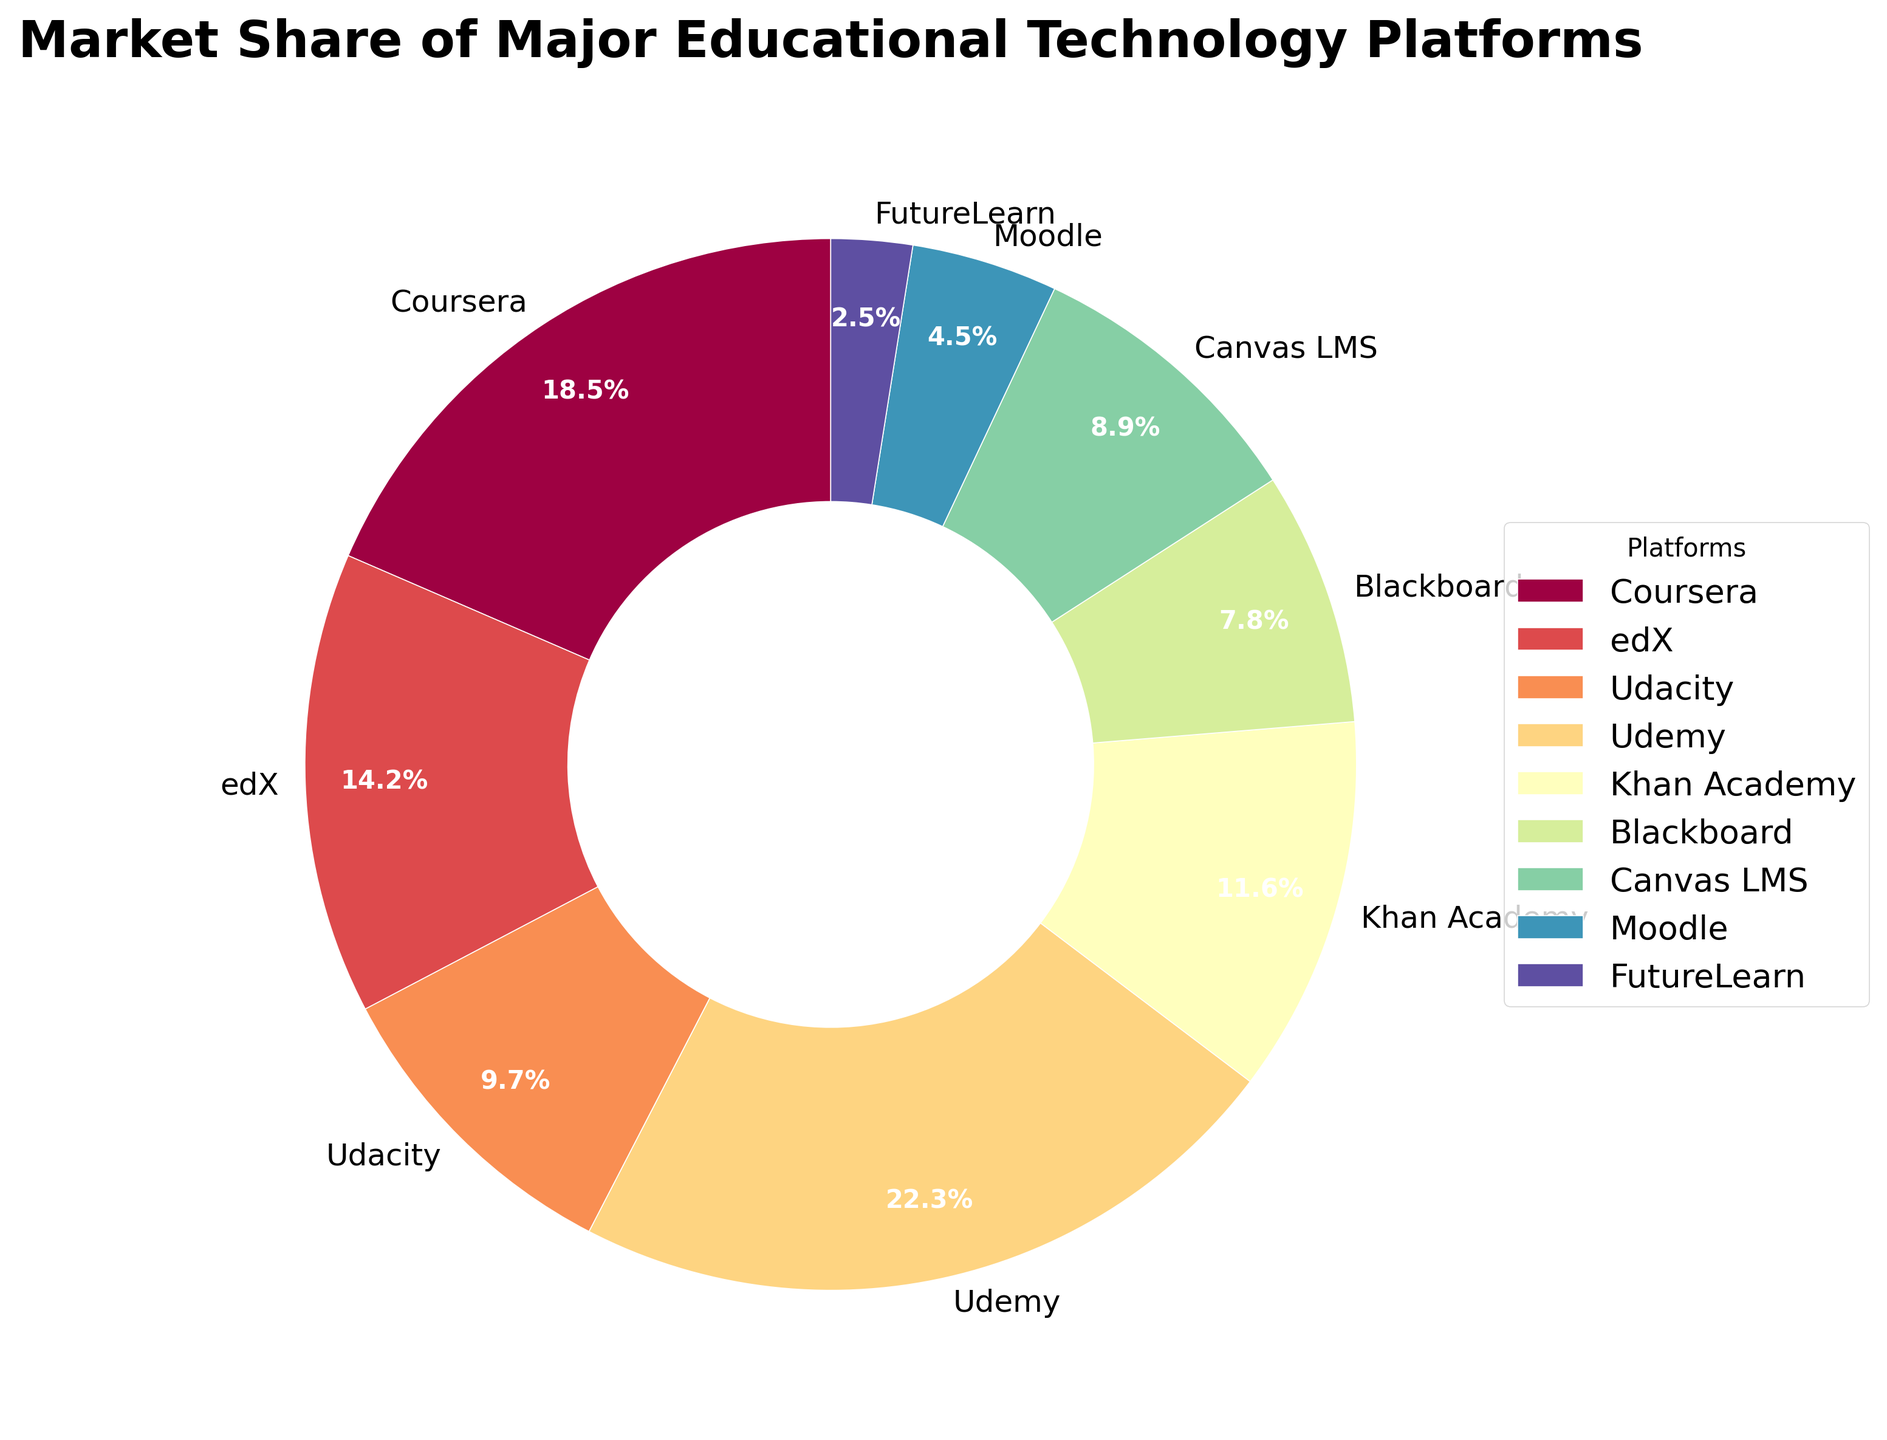Which platform has the largest market share? By looking at the pie chart, we can identify the platform with the largest slice. The label on the largest slice indicates "Udemy" with a market share of 22.3%.
Answer: Udemy Which two platforms together hold more than 30% market share? Summing up the shares of each platform, we see that Udemy has 22.3% and Coursera has 18.5%. Together, they account for 40.8%, which is more than 30%.
Answer: Udemy and Coursera Which platform has the smallest market share? By identifying the smallest slice in the pie chart, we can see that the label on it indicates "FutureLearn" with a market share of 2.5%.
Answer: FutureLearn What is the combined market share of edX and Khan Academy? Adding the market shares of edX (14.2%) and Khan Academy (11.6%), we get 14.2 + 11.6 = 25.8%.
Answer: 25.8% How does the market share of Blackboard compare to Canvas LMS? The market share of Blackboard is 7.8% whereas Canvas LMS has 8.9%. Comparing these, Canvas LMS has a slightly larger share.
Answer: Canvas LMS Between Coursera and Udacity, which platform has a higher market share, and by how much? Coursera has a market share of 18.5%, and Udacity has 9.7%. The difference in their market shares is 18.5 - 9.7 = 8.8%.
Answer: Coursera by 8.8% If the platforms were grouped into "Top 3" and "Others", what would be the market share of each group? The Top 3 platforms are Udemy (22.3%), Coursera (18.5%), and edX (14.2%). Their combined share is 22.3 + 18.5 + 14.2 = 55%. The Others group includes the remaining platforms, summing up to 45%.
Answer: Top 3: 55%, Others: 45% What is the average market share of the platforms with less than 10% market share? The platforms with less than 10% are Udacity (9.7%), Blackboard (7.8%), Canvas LMS (8.9%), Moodle (4.5%), and FutureLearn (2.5%). Their shares sum to 9.7 + 7.8 + 8.9 + 4.5 + 2.5 = 33.4%. The average is 33.4 / 5 = 6.68%.
Answer: 6.68% Which platforms have a market share between 10% and 20%? By examining the pie chart, the platforms with market shares in this range are Coursera (18.5%), edX (14.2%), and Khan Academy (11.6%).
Answer: Coursera, edX, Khan Academy Of the platforms not included in the Top 3, which has the highest market share? After removing the Top 3 (Udemy, Coursera, edX), the remaining platforms are Udacity, Khan Academy, Blackboard, Canvas LMS, Moodle, and FutureLearn. Among these, Khan Academy has the highest market share (11.6%).
Answer: Khan Academy 